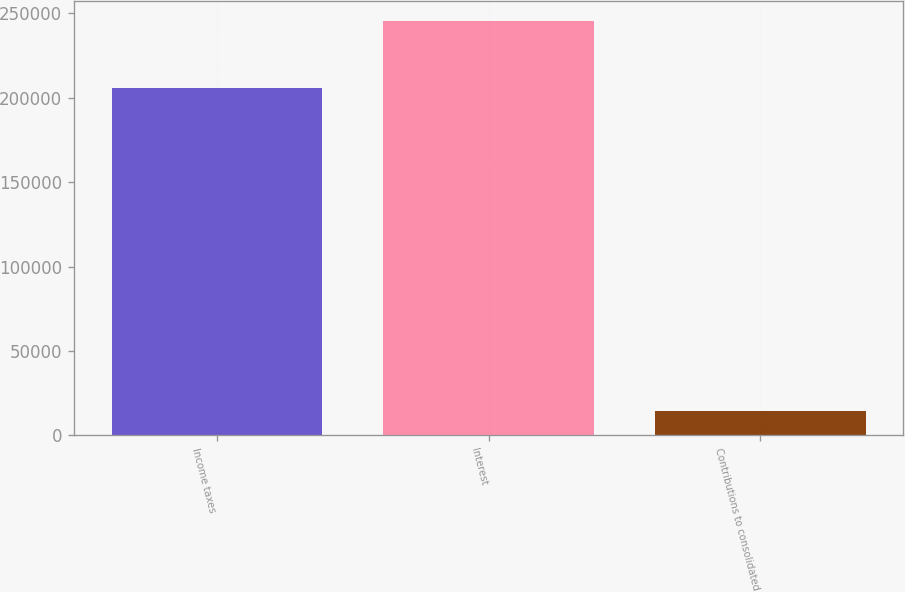<chart> <loc_0><loc_0><loc_500><loc_500><bar_chart><fcel>Income taxes<fcel>Interest<fcel>Contributions to consolidated<nl><fcel>205955<fcel>245325<fcel>14735<nl></chart> 